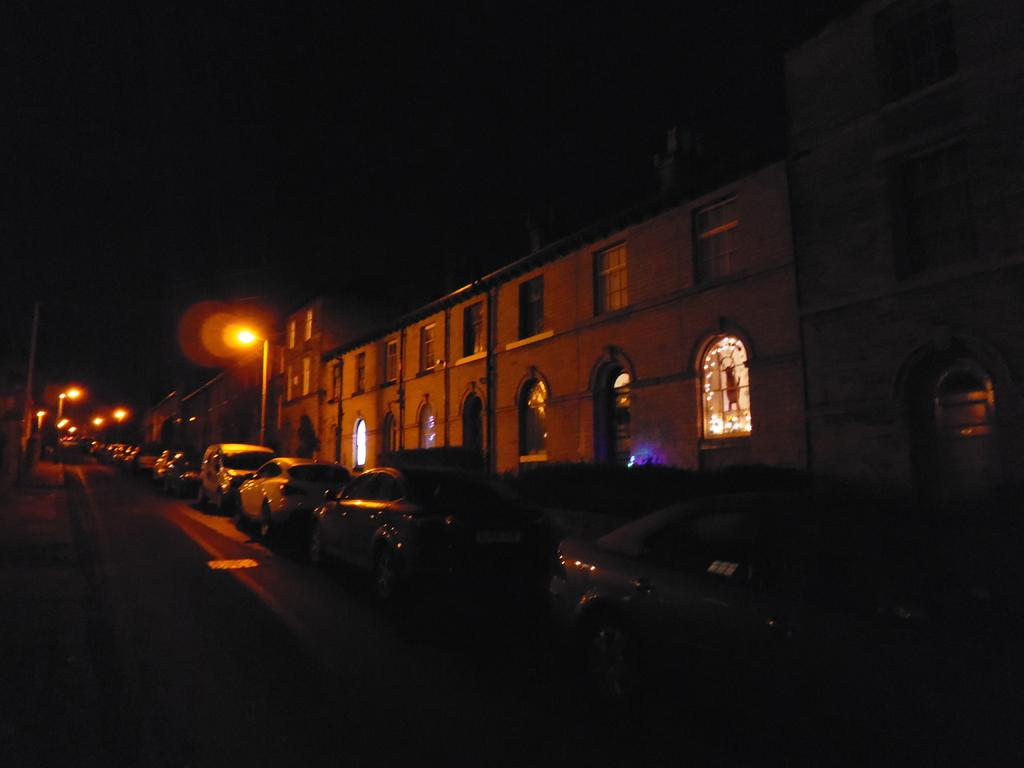What can be seen on the path in the image? There are vehicles on the path in the image. What structures are present in the image? There are poles, lights, and buildings in the image. What is visible in the background of the image? The sky is visible in the background of the image. What type of jam is being used to balance the pin in the image? There is no jam, pin, or balancing act present in the image. 